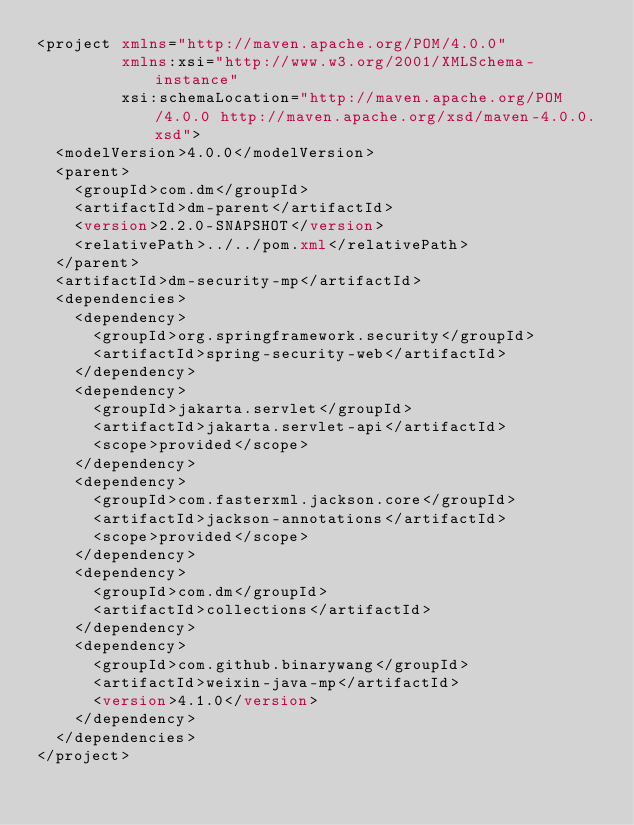Convert code to text. <code><loc_0><loc_0><loc_500><loc_500><_XML_><project xmlns="http://maven.apache.org/POM/4.0.0"
         xmlns:xsi="http://www.w3.org/2001/XMLSchema-instance"
         xsi:schemaLocation="http://maven.apache.org/POM/4.0.0 http://maven.apache.org/xsd/maven-4.0.0.xsd">
  <modelVersion>4.0.0</modelVersion>
  <parent>
    <groupId>com.dm</groupId>
    <artifactId>dm-parent</artifactId>
    <version>2.2.0-SNAPSHOT</version>
    <relativePath>../../pom.xml</relativePath>
  </parent>
  <artifactId>dm-security-mp</artifactId>
  <dependencies>
    <dependency>
      <groupId>org.springframework.security</groupId>
      <artifactId>spring-security-web</artifactId>
    </dependency>
    <dependency>
      <groupId>jakarta.servlet</groupId>
      <artifactId>jakarta.servlet-api</artifactId>
      <scope>provided</scope>
    </dependency>
    <dependency>
      <groupId>com.fasterxml.jackson.core</groupId>
      <artifactId>jackson-annotations</artifactId>
      <scope>provided</scope>
    </dependency>
    <dependency>
      <groupId>com.dm</groupId>
      <artifactId>collections</artifactId>
    </dependency>
    <dependency>
      <groupId>com.github.binarywang</groupId>
      <artifactId>weixin-java-mp</artifactId>
      <version>4.1.0</version>
    </dependency>
  </dependencies>
</project>
</code> 